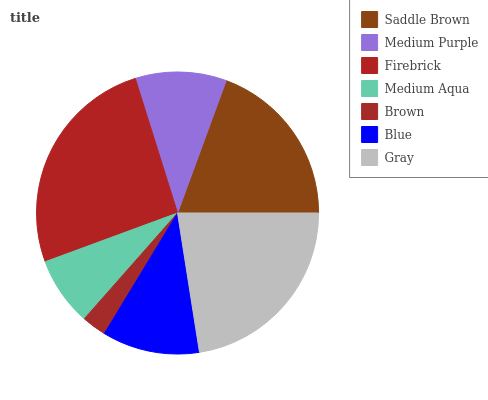Is Brown the minimum?
Answer yes or no. Yes. Is Firebrick the maximum?
Answer yes or no. Yes. Is Medium Purple the minimum?
Answer yes or no. No. Is Medium Purple the maximum?
Answer yes or no. No. Is Saddle Brown greater than Medium Purple?
Answer yes or no. Yes. Is Medium Purple less than Saddle Brown?
Answer yes or no. Yes. Is Medium Purple greater than Saddle Brown?
Answer yes or no. No. Is Saddle Brown less than Medium Purple?
Answer yes or no. No. Is Blue the high median?
Answer yes or no. Yes. Is Blue the low median?
Answer yes or no. Yes. Is Gray the high median?
Answer yes or no. No. Is Medium Aqua the low median?
Answer yes or no. No. 